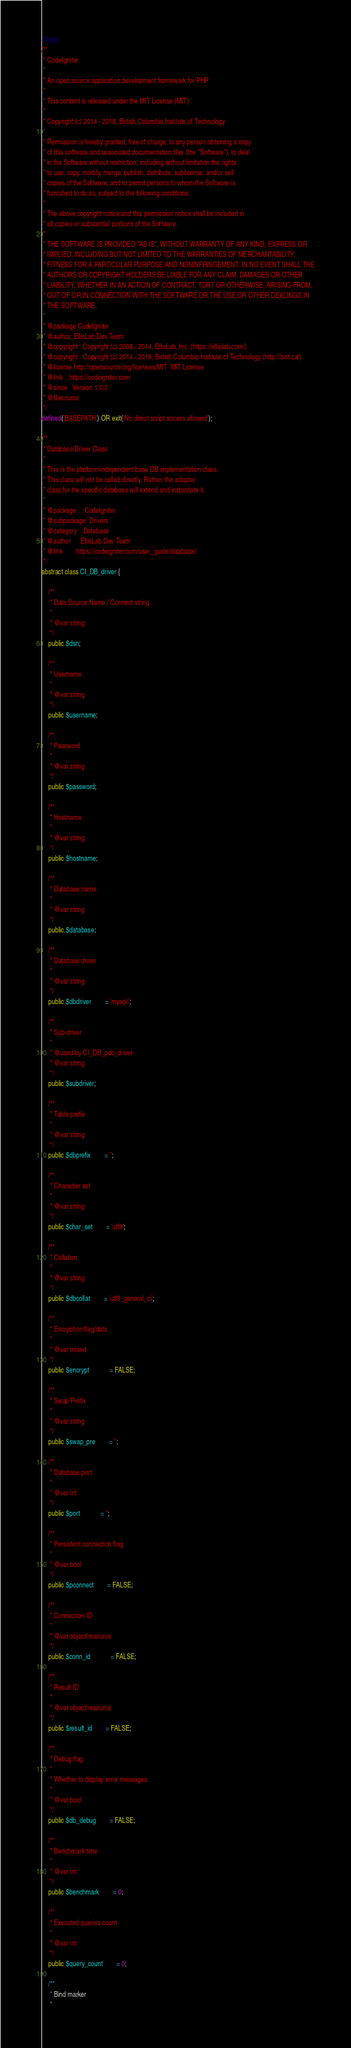Convert code to text. <code><loc_0><loc_0><loc_500><loc_500><_PHP_><?php
/**
 * CodeIgniter
 *
 * An open source application development framework for PHP
 *
 * This content is released under the MIT License (MIT)
 *
 * Copyright (c) 2014 - 2018, British Columbia Institute of Technology
 *
 * Permission is hereby granted, free of charge, to any person obtaining a copy
 * of this software and associated documentation files (the "Software"), to deal
 * in the Software without restriction, including without limitation the rights
 * to use, copy, modify, merge, publish, distribute, sublicense, and/or sell
 * copies of the Software, and to permit persons to whom the Software is
 * furnished to do so, subject to the following conditions:
 *
 * The above copyright notice and this permission notice shall be included in
 * all copies or substantial portions of the Software.
 *
 * THE SOFTWARE IS PROVIDED "AS IS", WITHOUT WARRANTY OF ANY KIND, EXPRESS OR
 * IMPLIED, INCLUDING BUT NOT LIMITED TO THE WARRANTIES OF MERCHANTABILITY,
 * FITNESS FOR A PARTICULAR PURPOSE AND NONINFRINGEMENT. IN NO EVENT SHALL THE
 * AUTHORS OR COPYRIGHT HOLDERS BE LIABLE FOR ANY CLAIM, DAMAGES OR OTHER
 * LIABILITY, WHETHER IN AN ACTION OF CONTRACT, TORT OR OTHERWISE, ARISING FROM,
 * OUT OF OR IN CONNECTION WITH THE SOFTWARE OR THE USE OR OTHER DEALINGS IN
 * THE SOFTWARE.
 *
 * @package	CodeIgniter
 * @author	EllisLab Dev Team
 * @copyright	Copyright (c) 2008 - 2014, EllisLab, Inc. (https://ellislab.com/)
 * @copyright	Copyright (c) 2014 - 2018, British Columbia Institute of Technology (http://bcit.ca/)
 * @license	http://opensource.org/licenses/MIT	MIT License
 * @link	https://codeigniter.com
 * @since	Version 1.0.0
 * @filesource
 */
defined('BASEPATH') OR exit('No direct script access allowed');

/**
 * Database Driver Class
 *
 * This is the platform-independent base DB implementation class.
 * This class will not be called directly. Rather, the adapter
 * class for the specific database will extend and instantiate it.
 *
 * @package		CodeIgniter
 * @subpackage	Drivers
 * @category	Database
 * @author		EllisLab Dev Team
 * @link		https://codeigniter.com/user_guide/database/
 */
abstract class CI_DB_driver {

	/**
	 * Data Source Name / Connect string
	 *
	 * @var	string
	 */
	public $dsn;

	/**
	 * Username
	 *
	 * @var	string
	 */
	public $username;

	/**
	 * Password
	 *
	 * @var	string
	 */
	public $password;

	/**
	 * Hostname
	 *
	 * @var	string
	 */
	public $hostname;

	/**
	 * Database name
	 *
	 * @var	string
	 */
	public $database;

	/**
	 * Database driver
	 *
	 * @var	string
	 */
	public $dbdriver		= 'mysqli';

	/**
	 * Sub-driver
	 *
	 * @used-by	CI_DB_pdo_driver
	 * @var	string
	 */
	public $subdriver;

	/**
	 * Table prefix
	 *
	 * @var	string
	 */
	public $dbprefix		= '';

	/**
	 * Character set
	 *
	 * @var	string
	 */
	public $char_set		= 'utf8';

	/**
	 * Collation
	 *
	 * @var	string
	 */
	public $dbcollat		= 'utf8_general_ci';

	/**
	 * Encryption flag/data
	 *
	 * @var	mixed
	 */
	public $encrypt			= FALSE;

	/**
	 * Swap Prefix
	 *
	 * @var	string
	 */
	public $swap_pre		= '';

	/**
	 * Database port
	 *
	 * @var	int
	 */
	public $port			= '';

	/**
	 * Persistent connection flag
	 *
	 * @var	bool
	 */
	public $pconnect		= FALSE;

	/**
	 * Connection ID
	 *
	 * @var	object|resource
	 */
	public $conn_id			= FALSE;

	/**
	 * Result ID
	 *
	 * @var	object|resource
	 */
	public $result_id		= FALSE;

	/**
	 * Debug flag
	 *
	 * Whether to display error messages.
	 *
	 * @var	bool
	 */
	public $db_debug		= FALSE;

	/**
	 * Benchmark time
	 *
	 * @var	int
	 */
	public $benchmark		= 0;

	/**
	 * Executed queries count
	 *
	 * @var	int
	 */
	public $query_count		= 0;

	/**
	 * Bind marker
	 *</code> 